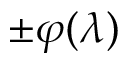<formula> <loc_0><loc_0><loc_500><loc_500>\pm \varphi ( \lambda )</formula> 